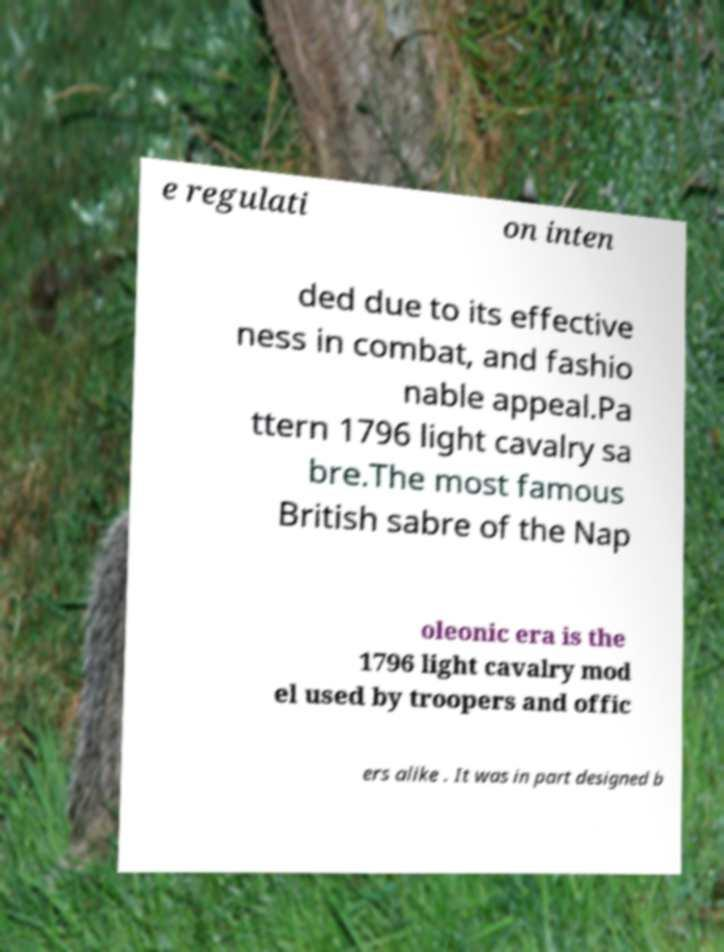I need the written content from this picture converted into text. Can you do that? e regulati on inten ded due to its effective ness in combat, and fashio nable appeal.Pa ttern 1796 light cavalry sa bre.The most famous British sabre of the Nap oleonic era is the 1796 light cavalry mod el used by troopers and offic ers alike . It was in part designed b 